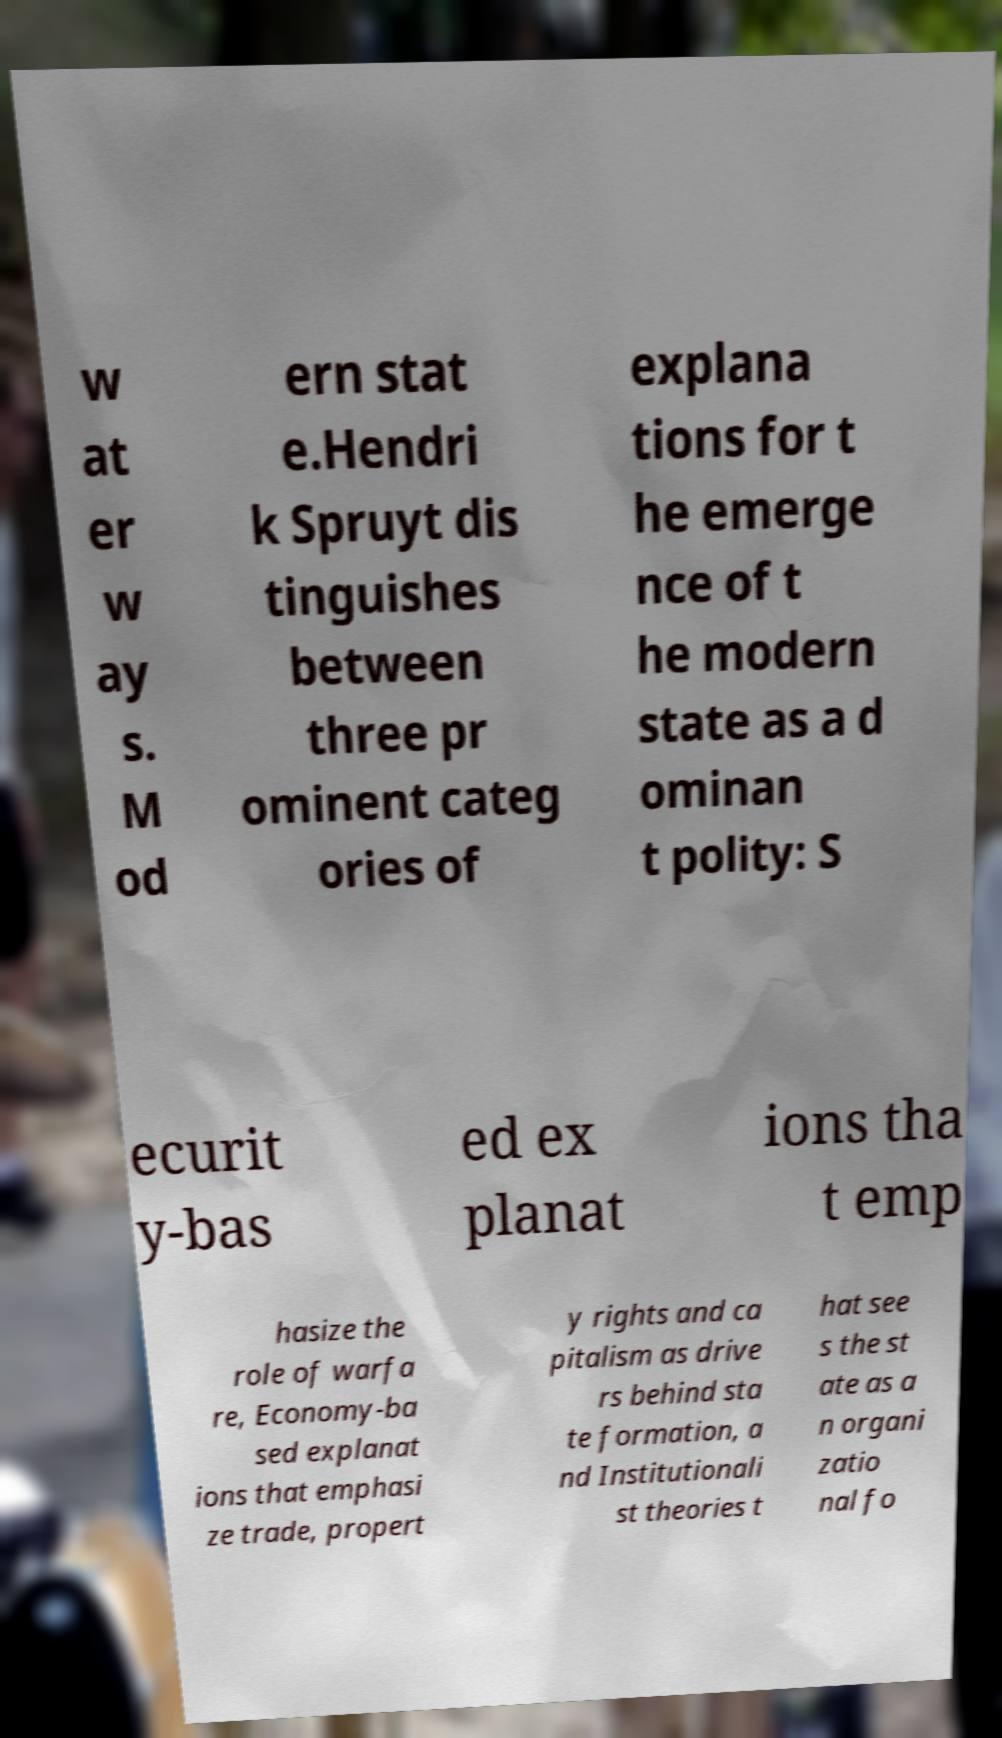Could you assist in decoding the text presented in this image and type it out clearly? w at er w ay s. M od ern stat e.Hendri k Spruyt dis tinguishes between three pr ominent categ ories of explana tions for t he emerge nce of t he modern state as a d ominan t polity: S ecurit y-bas ed ex planat ions tha t emp hasize the role of warfa re, Economy-ba sed explanat ions that emphasi ze trade, propert y rights and ca pitalism as drive rs behind sta te formation, a nd Institutionali st theories t hat see s the st ate as a n organi zatio nal fo 